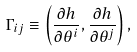<formula> <loc_0><loc_0><loc_500><loc_500>\Gamma _ { i j } \equiv \left ( \frac { \partial h } { \partial \theta ^ { i } } , \frac { \partial h } { \partial \theta ^ { j } } \right ) ,</formula> 